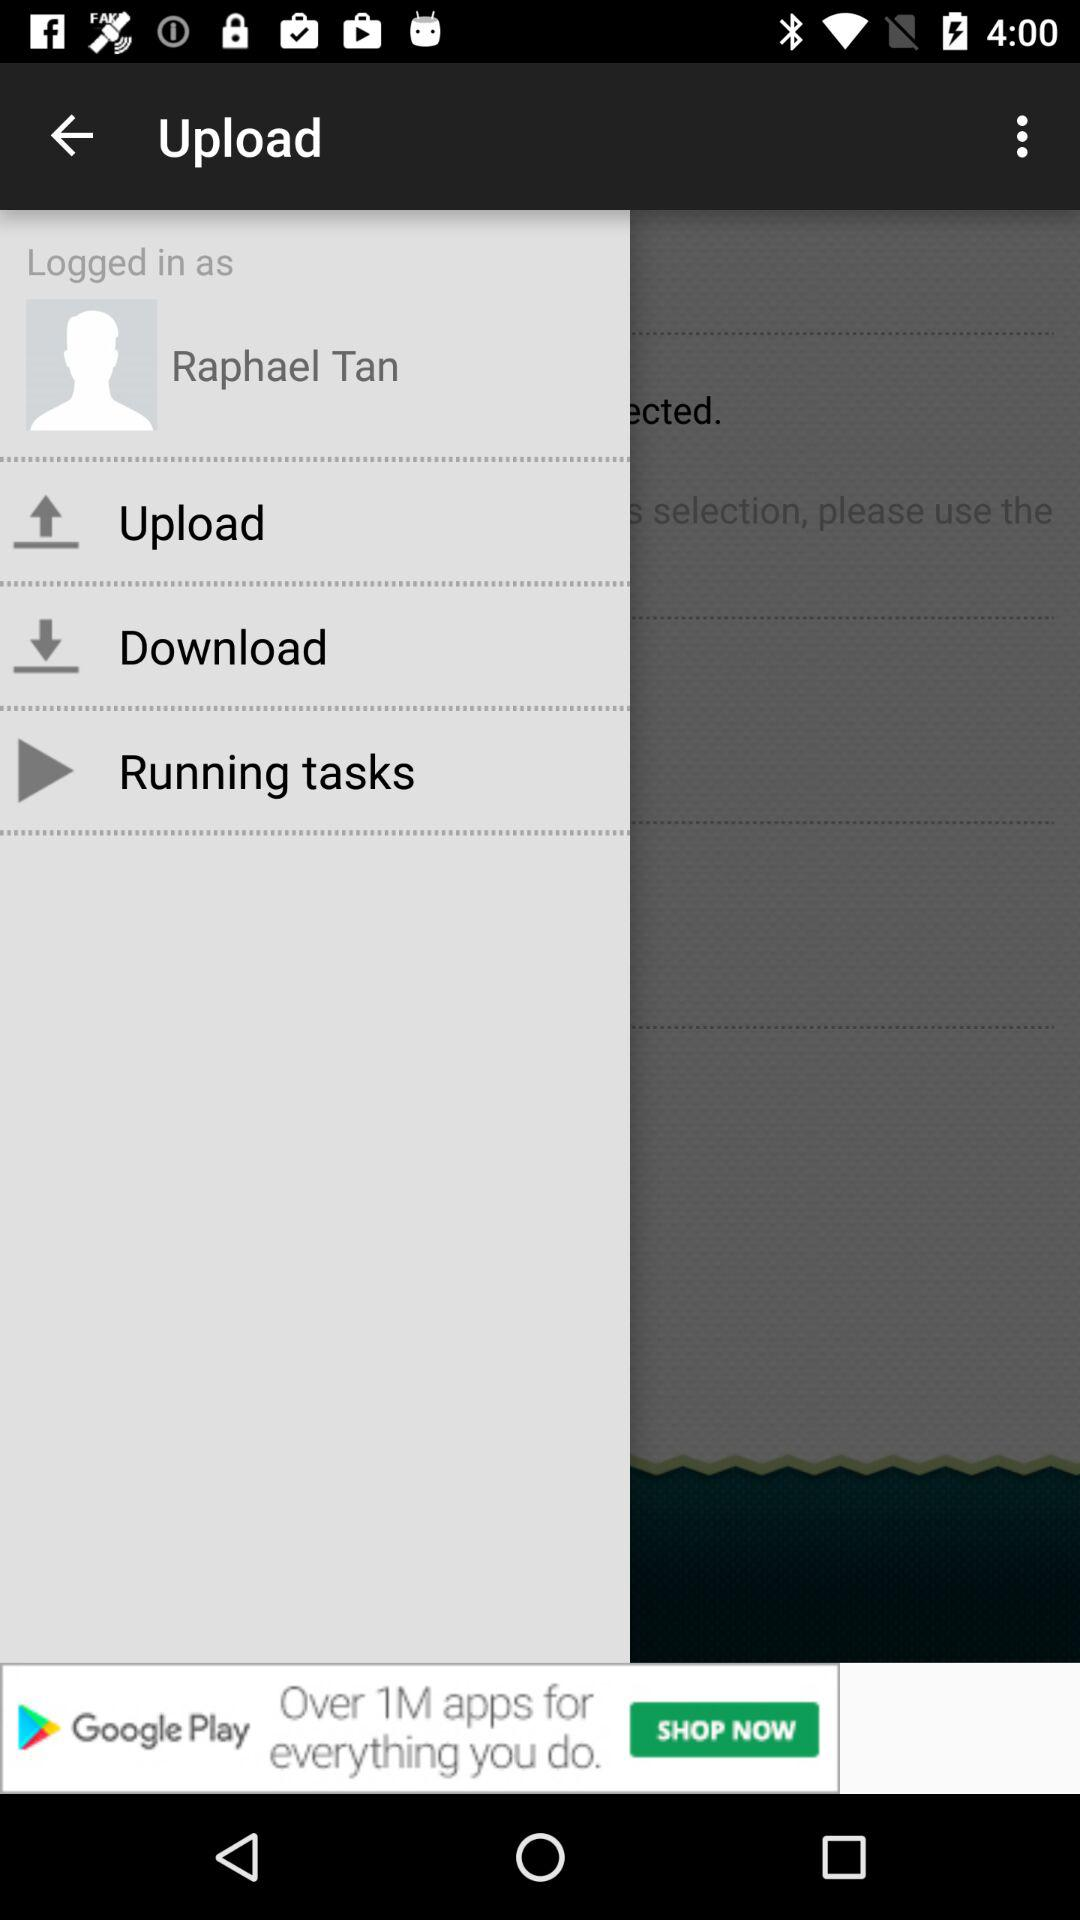Which item is being uploaded?
When the provided information is insufficient, respond with <no answer>. <no answer> 